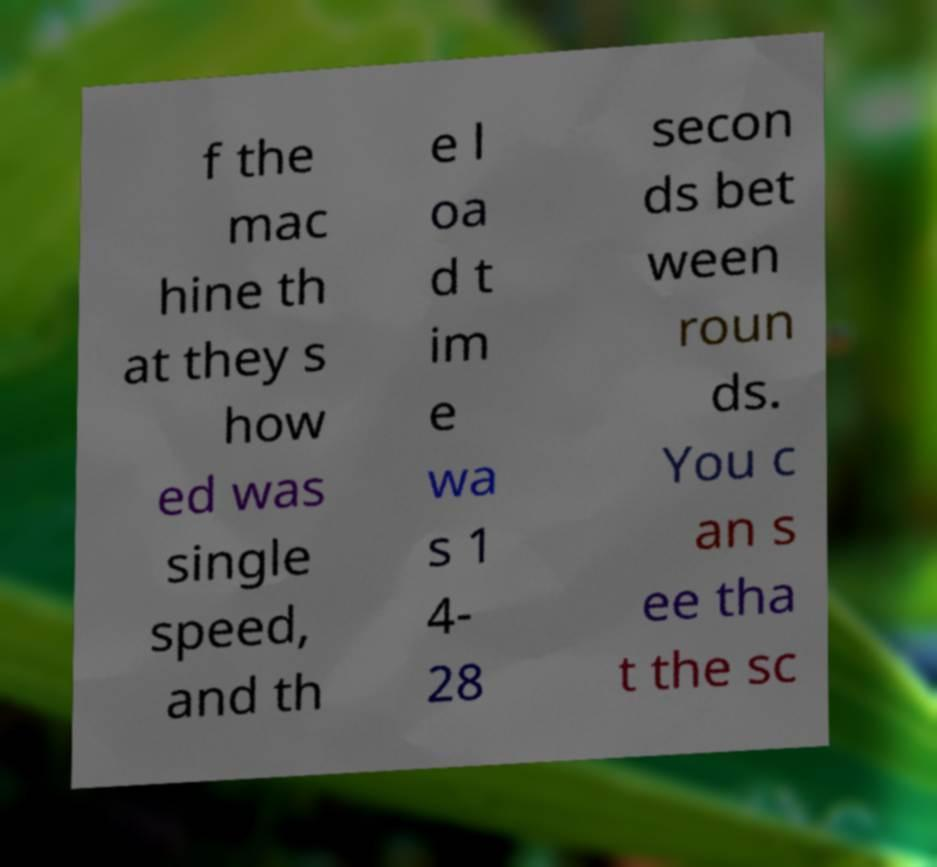Could you extract and type out the text from this image? f the mac hine th at they s how ed was single speed, and th e l oa d t im e wa s 1 4- 28 secon ds bet ween roun ds. You c an s ee tha t the sc 